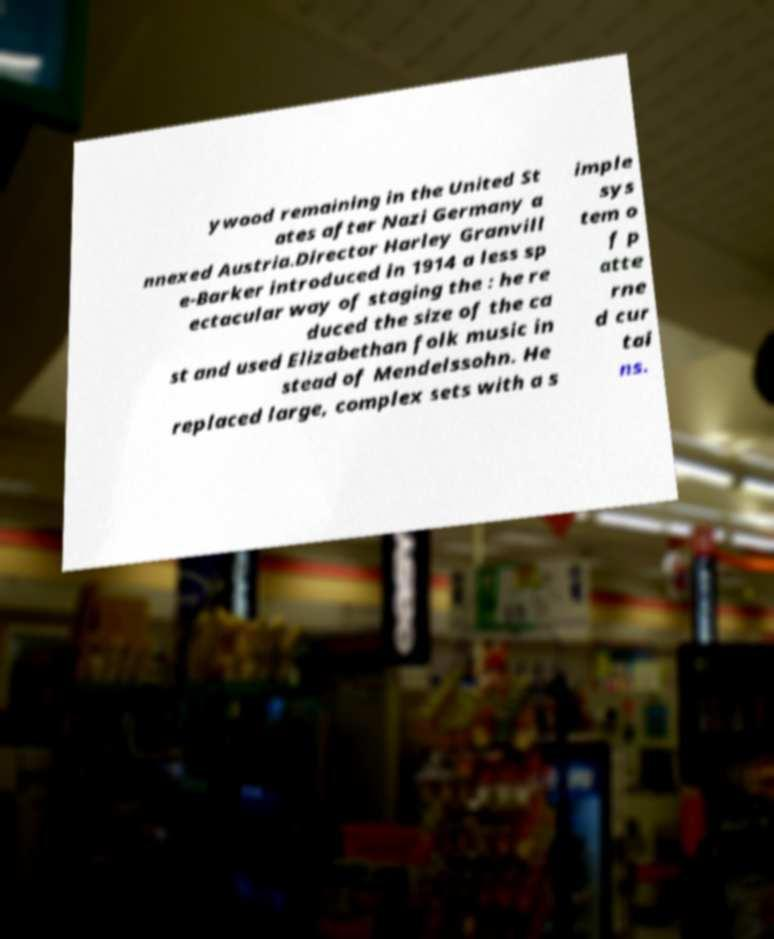Please read and relay the text visible in this image. What does it say? ywood remaining in the United St ates after Nazi Germany a nnexed Austria.Director Harley Granvill e-Barker introduced in 1914 a less sp ectacular way of staging the : he re duced the size of the ca st and used Elizabethan folk music in stead of Mendelssohn. He replaced large, complex sets with a s imple sys tem o f p atte rne d cur tai ns. 